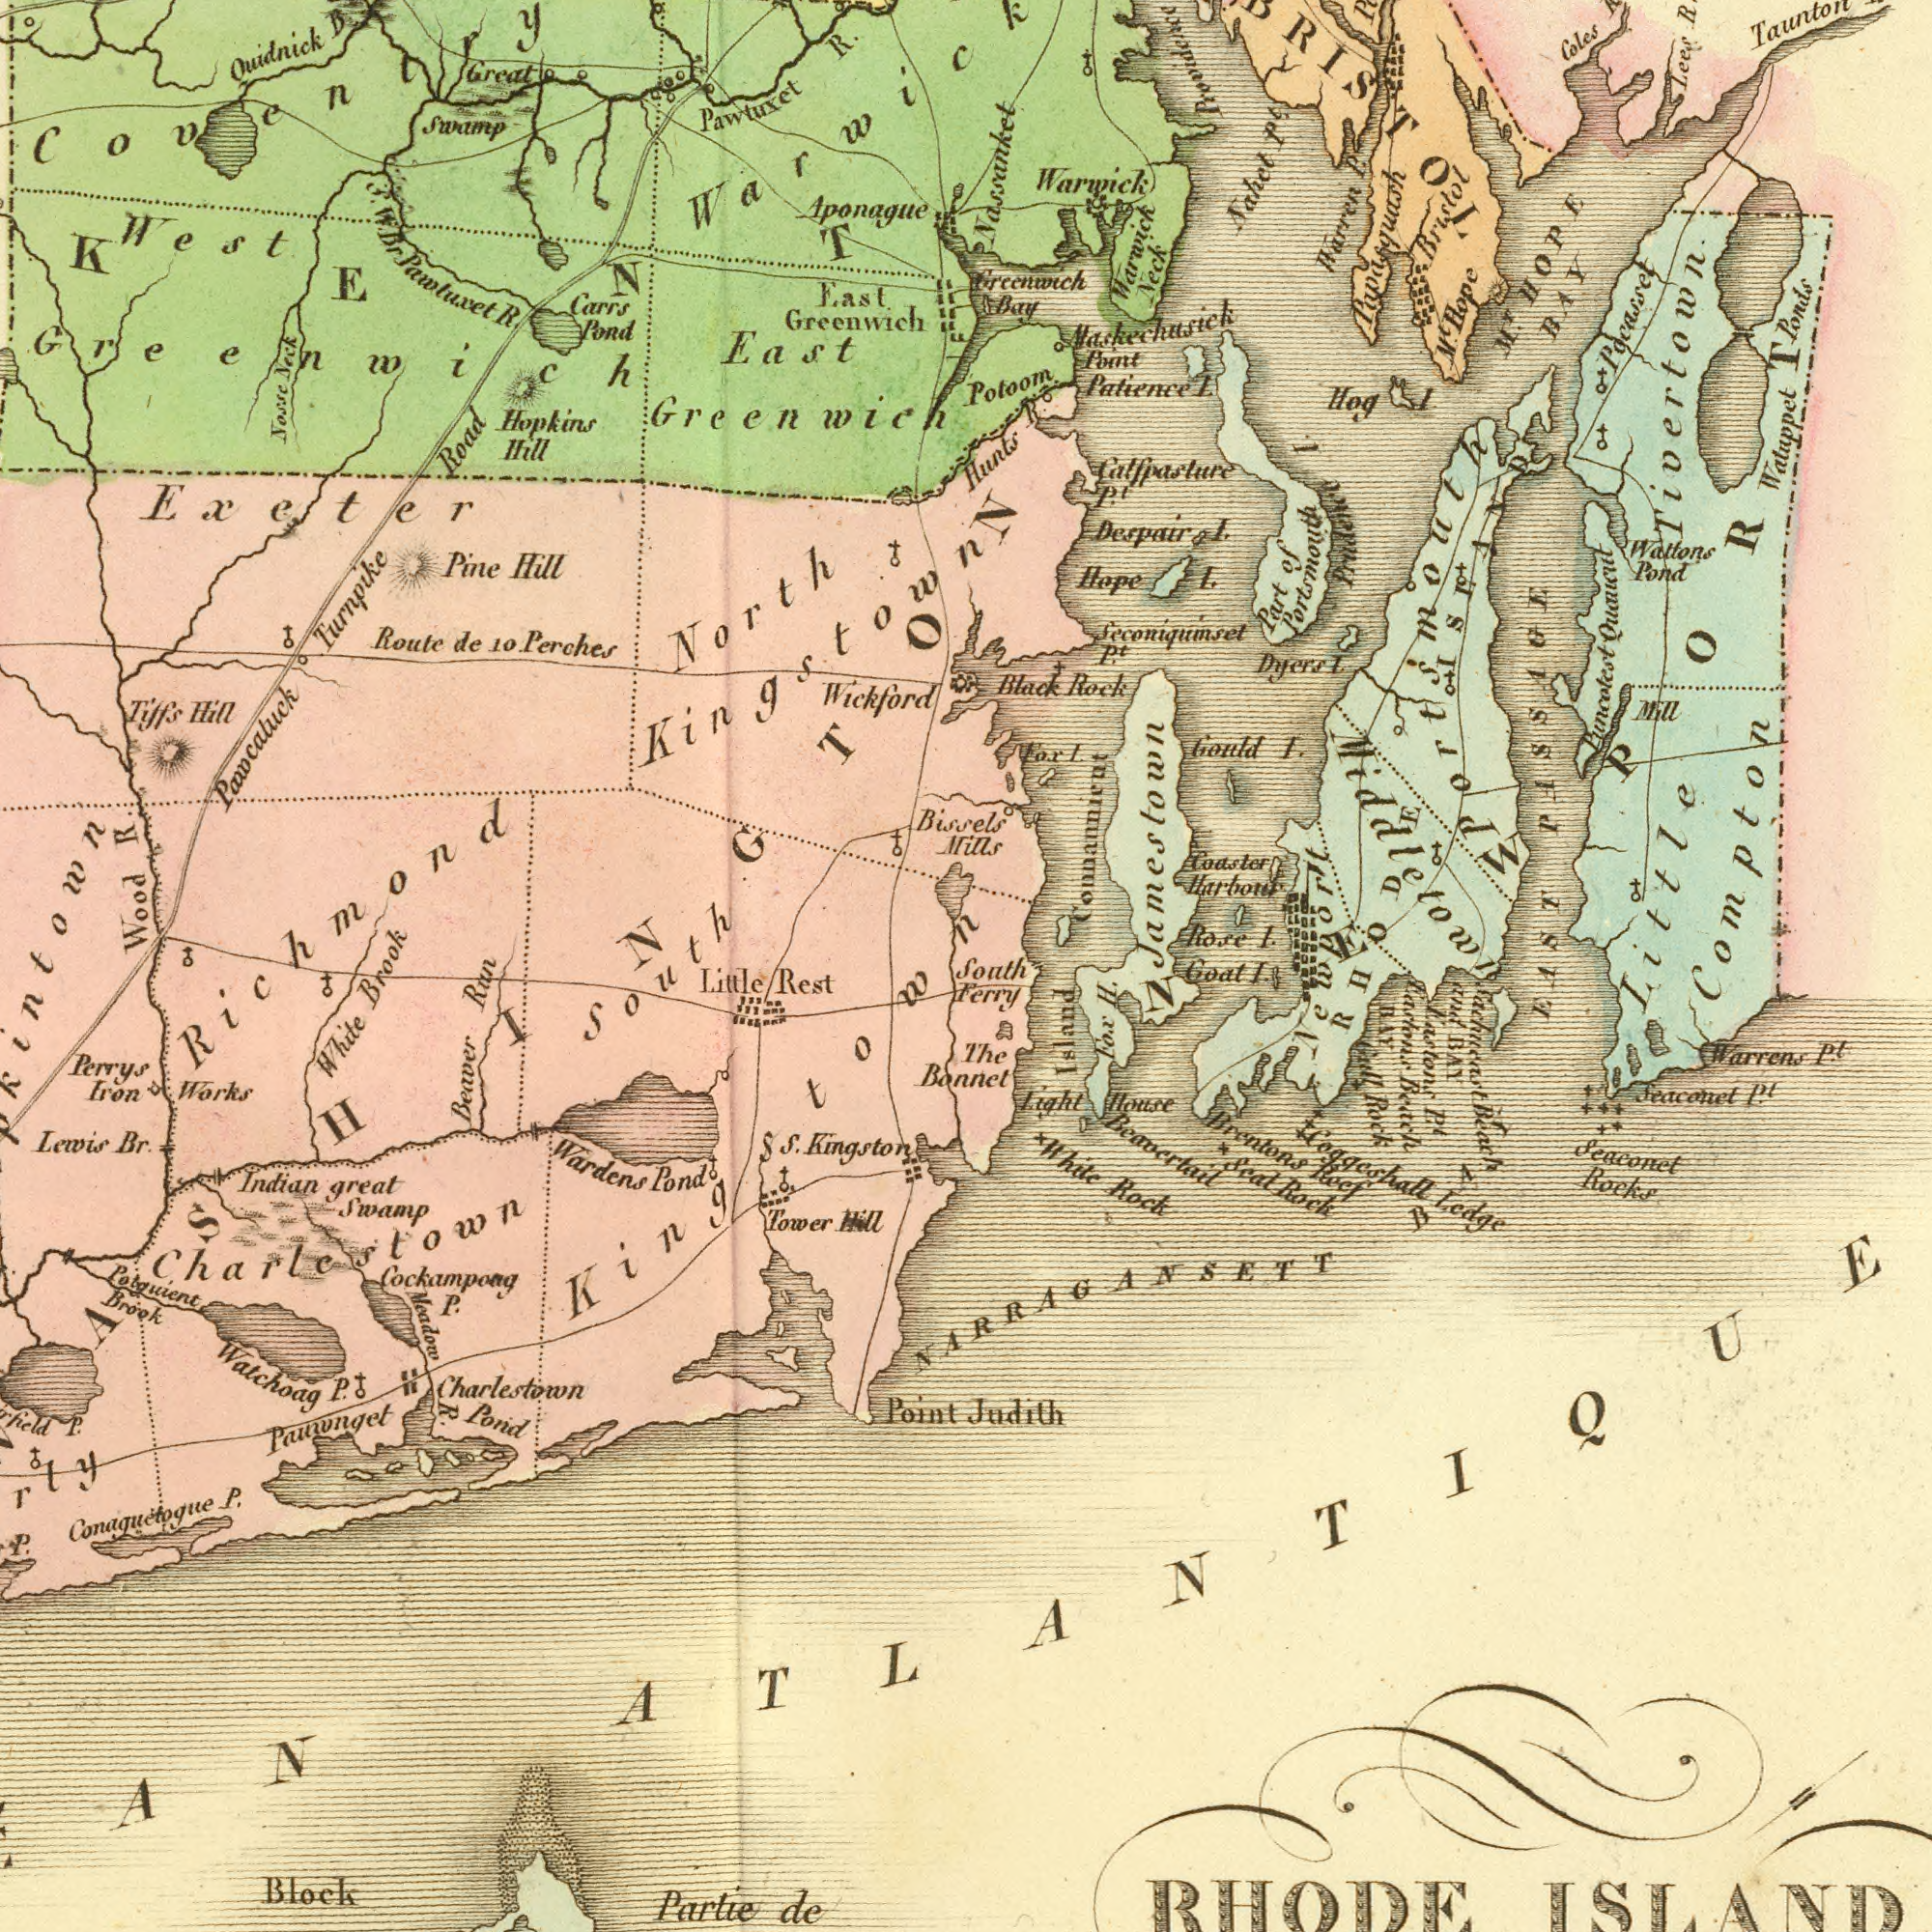What text can you see in the bottom-right section? BAY Island Judith The Bonnet Fox H. Brentons Roef Warrens Pt. Seaconet Rocks Beavertail Seaconet Pt. Coggesgall Ledge Light House White Rock Gill Rock Sead Rock Goat I. RHODE ISLAND NARRAGANSETT Saichnoast Beah and BAY Eadons Beach Knstons Pt. South Ferry BAY ATLANTIQUE What text can you see in the bottom-left section? Beaver Run Cockampong P. Lewis Br. Perrys Iron Works Block Wardens Pond Meadow R. S. Kingston Partie de Charlestown Pond Potguient Brook Point Indian great Swamp Little Rest Pauivnget White Tower Hill P. Watchoag P. Conaguetogue P. South Kingstown P. Charlestown What text is shown in the top-left quadrant? Wood R. East Greenwich North Kingstown Exeter East. Greenwich Pawtuxet R. Pawcaluck Turnpike Road Wickford Route de 10. Perches Hopkins Hill Swamp Quidnick Pine Hill Great W. Br. Pawtuxet R. Aponague Tiffs Hill Carrs Pond West Greenwich Nosse Nick Coventry Brook Richmond KENT What text is visible in the upper-right corner? Bissels Mills Waltons Pond Patience I. Watuppet Ponds Puncotest EAST PASSAOE Black Rock Part of Portsmouth Coles Taunton Potoom Mill Nassanket Hope I. Bristol Harren P Warwick Neck Lees R. Gould I. Coaster Harbor Nahet Pt. Rose I. Hog l. Greenwich Bay Dyers I. Seconiqumset Warwick Little Compton Despair I. Pt. Newport Haskechusick Point Pocasset Catfpasture Pt. Connannicut Fox I. Hunts R.O Mt. Hope Mr. HOPE BAY Prouidence Jamestown Prudence l. Portsmouth Tivertown. Papasquash RHODE ISLAND NEWPORT Middletown 